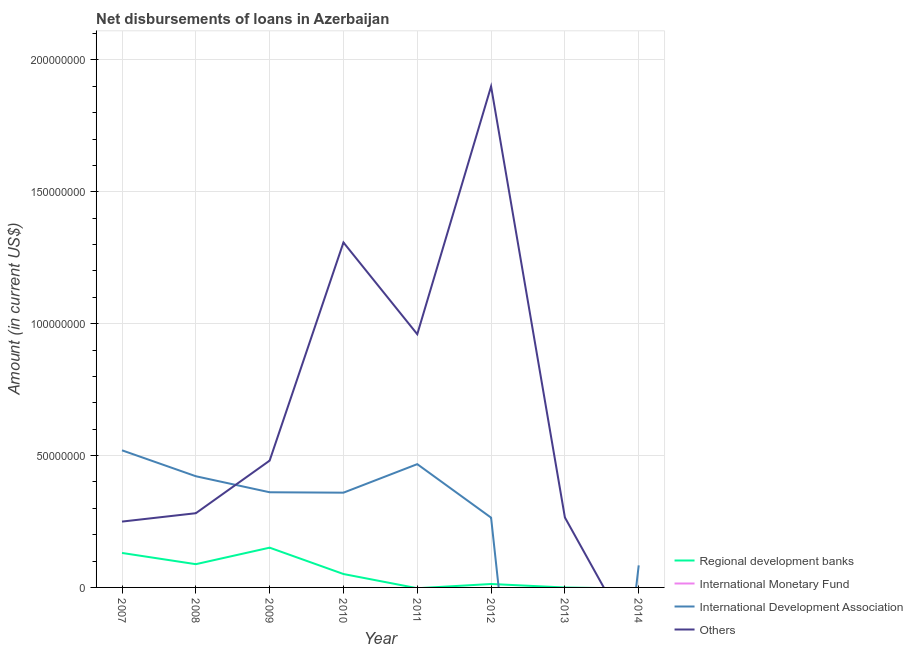Does the line corresponding to amount of loan disimbursed by other organisations intersect with the line corresponding to amount of loan disimbursed by international monetary fund?
Make the answer very short. Yes. What is the amount of loan disimbursed by international development association in 2008?
Make the answer very short. 4.22e+07. Across all years, what is the maximum amount of loan disimbursed by regional development banks?
Offer a terse response. 1.51e+07. Across all years, what is the minimum amount of loan disimbursed by international development association?
Your answer should be compact. 0. In which year was the amount of loan disimbursed by regional development banks maximum?
Offer a very short reply. 2009. What is the difference between the amount of loan disimbursed by regional development banks in 2007 and that in 2012?
Your answer should be compact. 1.18e+07. What is the difference between the amount of loan disimbursed by other organisations in 2009 and the amount of loan disimbursed by regional development banks in 2013?
Your answer should be compact. 4.81e+07. What is the average amount of loan disimbursed by other organisations per year?
Offer a very short reply. 6.81e+07. In the year 2007, what is the difference between the amount of loan disimbursed by international development association and amount of loan disimbursed by regional development banks?
Your answer should be very brief. 3.89e+07. What is the ratio of the amount of loan disimbursed by other organisations in 2007 to that in 2008?
Keep it short and to the point. 0.89. Is the amount of loan disimbursed by international development association in 2010 less than that in 2011?
Your response must be concise. Yes. What is the difference between the highest and the second highest amount of loan disimbursed by other organisations?
Offer a terse response. 5.92e+07. What is the difference between the highest and the lowest amount of loan disimbursed by other organisations?
Make the answer very short. 1.90e+08. In how many years, is the amount of loan disimbursed by other organisations greater than the average amount of loan disimbursed by other organisations taken over all years?
Offer a very short reply. 3. Is the sum of the amount of loan disimbursed by regional development banks in 2007 and 2010 greater than the maximum amount of loan disimbursed by other organisations across all years?
Provide a succinct answer. No. Is it the case that in every year, the sum of the amount of loan disimbursed by regional development banks and amount of loan disimbursed by international monetary fund is greater than the amount of loan disimbursed by international development association?
Keep it short and to the point. No. Does the amount of loan disimbursed by other organisations monotonically increase over the years?
Ensure brevity in your answer.  No. How many years are there in the graph?
Make the answer very short. 8. What is the difference between two consecutive major ticks on the Y-axis?
Make the answer very short. 5.00e+07. Does the graph contain grids?
Your answer should be very brief. Yes. What is the title of the graph?
Give a very brief answer. Net disbursements of loans in Azerbaijan. Does "Minerals" appear as one of the legend labels in the graph?
Keep it short and to the point. No. What is the label or title of the X-axis?
Give a very brief answer. Year. What is the label or title of the Y-axis?
Your answer should be very brief. Amount (in current US$). What is the Amount (in current US$) of Regional development banks in 2007?
Offer a very short reply. 1.31e+07. What is the Amount (in current US$) in International Monetary Fund in 2007?
Keep it short and to the point. 0. What is the Amount (in current US$) in International Development Association in 2007?
Provide a short and direct response. 5.20e+07. What is the Amount (in current US$) in Others in 2007?
Your answer should be compact. 2.50e+07. What is the Amount (in current US$) in Regional development banks in 2008?
Offer a terse response. 8.81e+06. What is the Amount (in current US$) of International Monetary Fund in 2008?
Give a very brief answer. 0. What is the Amount (in current US$) of International Development Association in 2008?
Offer a very short reply. 4.22e+07. What is the Amount (in current US$) of Others in 2008?
Your answer should be very brief. 2.81e+07. What is the Amount (in current US$) of Regional development banks in 2009?
Provide a succinct answer. 1.51e+07. What is the Amount (in current US$) in International Monetary Fund in 2009?
Offer a terse response. 0. What is the Amount (in current US$) in International Development Association in 2009?
Offer a terse response. 3.61e+07. What is the Amount (in current US$) of Others in 2009?
Your answer should be compact. 4.81e+07. What is the Amount (in current US$) of Regional development banks in 2010?
Provide a short and direct response. 5.08e+06. What is the Amount (in current US$) of International Development Association in 2010?
Your response must be concise. 3.59e+07. What is the Amount (in current US$) in Others in 2010?
Make the answer very short. 1.31e+08. What is the Amount (in current US$) of International Development Association in 2011?
Provide a short and direct response. 4.67e+07. What is the Amount (in current US$) in Others in 2011?
Provide a short and direct response. 9.60e+07. What is the Amount (in current US$) in Regional development banks in 2012?
Your answer should be compact. 1.30e+06. What is the Amount (in current US$) of International Development Association in 2012?
Offer a terse response. 2.65e+07. What is the Amount (in current US$) of Others in 2012?
Ensure brevity in your answer.  1.90e+08. What is the Amount (in current US$) of International Monetary Fund in 2013?
Ensure brevity in your answer.  0. What is the Amount (in current US$) of International Development Association in 2013?
Your response must be concise. 0. What is the Amount (in current US$) of Others in 2013?
Give a very brief answer. 2.65e+07. What is the Amount (in current US$) in Regional development banks in 2014?
Make the answer very short. 0. What is the Amount (in current US$) of International Development Association in 2014?
Keep it short and to the point. 8.36e+06. Across all years, what is the maximum Amount (in current US$) in Regional development banks?
Your answer should be compact. 1.51e+07. Across all years, what is the maximum Amount (in current US$) in International Development Association?
Ensure brevity in your answer.  5.20e+07. Across all years, what is the maximum Amount (in current US$) in Others?
Ensure brevity in your answer.  1.90e+08. Across all years, what is the minimum Amount (in current US$) of International Development Association?
Your answer should be compact. 0. What is the total Amount (in current US$) in Regional development banks in the graph?
Your answer should be compact. 4.33e+07. What is the total Amount (in current US$) in International Development Association in the graph?
Ensure brevity in your answer.  2.48e+08. What is the total Amount (in current US$) of Others in the graph?
Provide a succinct answer. 5.44e+08. What is the difference between the Amount (in current US$) in Regional development banks in 2007 and that in 2008?
Keep it short and to the point. 4.26e+06. What is the difference between the Amount (in current US$) of International Development Association in 2007 and that in 2008?
Your response must be concise. 9.82e+06. What is the difference between the Amount (in current US$) of Others in 2007 and that in 2008?
Ensure brevity in your answer.  -3.17e+06. What is the difference between the Amount (in current US$) of Regional development banks in 2007 and that in 2009?
Offer a very short reply. -2.00e+06. What is the difference between the Amount (in current US$) of International Development Association in 2007 and that in 2009?
Your response must be concise. 1.59e+07. What is the difference between the Amount (in current US$) of Others in 2007 and that in 2009?
Give a very brief answer. -2.31e+07. What is the difference between the Amount (in current US$) in Regional development banks in 2007 and that in 2010?
Your response must be concise. 7.98e+06. What is the difference between the Amount (in current US$) in International Development Association in 2007 and that in 2010?
Make the answer very short. 1.61e+07. What is the difference between the Amount (in current US$) of Others in 2007 and that in 2010?
Offer a very short reply. -1.06e+08. What is the difference between the Amount (in current US$) of International Development Association in 2007 and that in 2011?
Offer a very short reply. 5.24e+06. What is the difference between the Amount (in current US$) in Others in 2007 and that in 2011?
Your answer should be compact. -7.10e+07. What is the difference between the Amount (in current US$) of Regional development banks in 2007 and that in 2012?
Offer a terse response. 1.18e+07. What is the difference between the Amount (in current US$) in International Development Association in 2007 and that in 2012?
Give a very brief answer. 2.55e+07. What is the difference between the Amount (in current US$) in Others in 2007 and that in 2012?
Your answer should be compact. -1.65e+08. What is the difference between the Amount (in current US$) of Others in 2007 and that in 2013?
Your response must be concise. -1.57e+06. What is the difference between the Amount (in current US$) of International Development Association in 2007 and that in 2014?
Provide a short and direct response. 4.36e+07. What is the difference between the Amount (in current US$) in Regional development banks in 2008 and that in 2009?
Provide a succinct answer. -6.26e+06. What is the difference between the Amount (in current US$) of International Development Association in 2008 and that in 2009?
Your answer should be very brief. 6.08e+06. What is the difference between the Amount (in current US$) of Others in 2008 and that in 2009?
Your answer should be compact. -1.99e+07. What is the difference between the Amount (in current US$) of Regional development banks in 2008 and that in 2010?
Your answer should be compact. 3.73e+06. What is the difference between the Amount (in current US$) in International Development Association in 2008 and that in 2010?
Your response must be concise. 6.23e+06. What is the difference between the Amount (in current US$) of Others in 2008 and that in 2010?
Your answer should be compact. -1.03e+08. What is the difference between the Amount (in current US$) of International Development Association in 2008 and that in 2011?
Provide a short and direct response. -4.58e+06. What is the difference between the Amount (in current US$) of Others in 2008 and that in 2011?
Ensure brevity in your answer.  -6.79e+07. What is the difference between the Amount (in current US$) in Regional development banks in 2008 and that in 2012?
Keep it short and to the point. 7.52e+06. What is the difference between the Amount (in current US$) of International Development Association in 2008 and that in 2012?
Your response must be concise. 1.57e+07. What is the difference between the Amount (in current US$) in Others in 2008 and that in 2012?
Your answer should be very brief. -1.62e+08. What is the difference between the Amount (in current US$) in Others in 2008 and that in 2013?
Provide a short and direct response. 1.60e+06. What is the difference between the Amount (in current US$) in International Development Association in 2008 and that in 2014?
Your response must be concise. 3.38e+07. What is the difference between the Amount (in current US$) of Regional development banks in 2009 and that in 2010?
Your response must be concise. 9.99e+06. What is the difference between the Amount (in current US$) in International Development Association in 2009 and that in 2010?
Give a very brief answer. 1.56e+05. What is the difference between the Amount (in current US$) in Others in 2009 and that in 2010?
Ensure brevity in your answer.  -8.27e+07. What is the difference between the Amount (in current US$) in International Development Association in 2009 and that in 2011?
Give a very brief answer. -1.07e+07. What is the difference between the Amount (in current US$) of Others in 2009 and that in 2011?
Your response must be concise. -4.79e+07. What is the difference between the Amount (in current US$) of Regional development banks in 2009 and that in 2012?
Provide a succinct answer. 1.38e+07. What is the difference between the Amount (in current US$) of International Development Association in 2009 and that in 2012?
Your answer should be very brief. 9.63e+06. What is the difference between the Amount (in current US$) in Others in 2009 and that in 2012?
Ensure brevity in your answer.  -1.42e+08. What is the difference between the Amount (in current US$) of Others in 2009 and that in 2013?
Offer a terse response. 2.15e+07. What is the difference between the Amount (in current US$) in International Development Association in 2009 and that in 2014?
Give a very brief answer. 2.77e+07. What is the difference between the Amount (in current US$) in International Development Association in 2010 and that in 2011?
Offer a terse response. -1.08e+07. What is the difference between the Amount (in current US$) of Others in 2010 and that in 2011?
Keep it short and to the point. 3.48e+07. What is the difference between the Amount (in current US$) in Regional development banks in 2010 and that in 2012?
Give a very brief answer. 3.79e+06. What is the difference between the Amount (in current US$) in International Development Association in 2010 and that in 2012?
Provide a short and direct response. 9.47e+06. What is the difference between the Amount (in current US$) of Others in 2010 and that in 2012?
Make the answer very short. -5.92e+07. What is the difference between the Amount (in current US$) of Others in 2010 and that in 2013?
Offer a very short reply. 1.04e+08. What is the difference between the Amount (in current US$) of International Development Association in 2010 and that in 2014?
Provide a succinct answer. 2.76e+07. What is the difference between the Amount (in current US$) of International Development Association in 2011 and that in 2012?
Your answer should be compact. 2.03e+07. What is the difference between the Amount (in current US$) in Others in 2011 and that in 2012?
Your response must be concise. -9.39e+07. What is the difference between the Amount (in current US$) in Others in 2011 and that in 2013?
Your answer should be very brief. 6.95e+07. What is the difference between the Amount (in current US$) in International Development Association in 2011 and that in 2014?
Provide a succinct answer. 3.84e+07. What is the difference between the Amount (in current US$) in Others in 2012 and that in 2013?
Offer a very short reply. 1.63e+08. What is the difference between the Amount (in current US$) of International Development Association in 2012 and that in 2014?
Offer a terse response. 1.81e+07. What is the difference between the Amount (in current US$) in Regional development banks in 2007 and the Amount (in current US$) in International Development Association in 2008?
Make the answer very short. -2.91e+07. What is the difference between the Amount (in current US$) of Regional development banks in 2007 and the Amount (in current US$) of Others in 2008?
Your answer should be very brief. -1.51e+07. What is the difference between the Amount (in current US$) of International Development Association in 2007 and the Amount (in current US$) of Others in 2008?
Offer a terse response. 2.38e+07. What is the difference between the Amount (in current US$) in Regional development banks in 2007 and the Amount (in current US$) in International Development Association in 2009?
Your answer should be very brief. -2.30e+07. What is the difference between the Amount (in current US$) of Regional development banks in 2007 and the Amount (in current US$) of Others in 2009?
Offer a very short reply. -3.50e+07. What is the difference between the Amount (in current US$) of International Development Association in 2007 and the Amount (in current US$) of Others in 2009?
Offer a terse response. 3.90e+06. What is the difference between the Amount (in current US$) in Regional development banks in 2007 and the Amount (in current US$) in International Development Association in 2010?
Provide a short and direct response. -2.29e+07. What is the difference between the Amount (in current US$) of Regional development banks in 2007 and the Amount (in current US$) of Others in 2010?
Make the answer very short. -1.18e+08. What is the difference between the Amount (in current US$) of International Development Association in 2007 and the Amount (in current US$) of Others in 2010?
Offer a very short reply. -7.88e+07. What is the difference between the Amount (in current US$) of Regional development banks in 2007 and the Amount (in current US$) of International Development Association in 2011?
Your response must be concise. -3.37e+07. What is the difference between the Amount (in current US$) in Regional development banks in 2007 and the Amount (in current US$) in Others in 2011?
Make the answer very short. -8.29e+07. What is the difference between the Amount (in current US$) of International Development Association in 2007 and the Amount (in current US$) of Others in 2011?
Ensure brevity in your answer.  -4.40e+07. What is the difference between the Amount (in current US$) in Regional development banks in 2007 and the Amount (in current US$) in International Development Association in 2012?
Ensure brevity in your answer.  -1.34e+07. What is the difference between the Amount (in current US$) of Regional development banks in 2007 and the Amount (in current US$) of Others in 2012?
Your answer should be very brief. -1.77e+08. What is the difference between the Amount (in current US$) of International Development Association in 2007 and the Amount (in current US$) of Others in 2012?
Make the answer very short. -1.38e+08. What is the difference between the Amount (in current US$) of Regional development banks in 2007 and the Amount (in current US$) of Others in 2013?
Keep it short and to the point. -1.35e+07. What is the difference between the Amount (in current US$) in International Development Association in 2007 and the Amount (in current US$) in Others in 2013?
Provide a short and direct response. 2.54e+07. What is the difference between the Amount (in current US$) of Regional development banks in 2007 and the Amount (in current US$) of International Development Association in 2014?
Your response must be concise. 4.71e+06. What is the difference between the Amount (in current US$) of Regional development banks in 2008 and the Amount (in current US$) of International Development Association in 2009?
Your response must be concise. -2.73e+07. What is the difference between the Amount (in current US$) of Regional development banks in 2008 and the Amount (in current US$) of Others in 2009?
Give a very brief answer. -3.93e+07. What is the difference between the Amount (in current US$) in International Development Association in 2008 and the Amount (in current US$) in Others in 2009?
Keep it short and to the point. -5.92e+06. What is the difference between the Amount (in current US$) in Regional development banks in 2008 and the Amount (in current US$) in International Development Association in 2010?
Offer a terse response. -2.71e+07. What is the difference between the Amount (in current US$) of Regional development banks in 2008 and the Amount (in current US$) of Others in 2010?
Keep it short and to the point. -1.22e+08. What is the difference between the Amount (in current US$) of International Development Association in 2008 and the Amount (in current US$) of Others in 2010?
Ensure brevity in your answer.  -8.86e+07. What is the difference between the Amount (in current US$) in Regional development banks in 2008 and the Amount (in current US$) in International Development Association in 2011?
Make the answer very short. -3.79e+07. What is the difference between the Amount (in current US$) in Regional development banks in 2008 and the Amount (in current US$) in Others in 2011?
Offer a very short reply. -8.72e+07. What is the difference between the Amount (in current US$) of International Development Association in 2008 and the Amount (in current US$) of Others in 2011?
Your response must be concise. -5.39e+07. What is the difference between the Amount (in current US$) in Regional development banks in 2008 and the Amount (in current US$) in International Development Association in 2012?
Provide a short and direct response. -1.76e+07. What is the difference between the Amount (in current US$) in Regional development banks in 2008 and the Amount (in current US$) in Others in 2012?
Offer a terse response. -1.81e+08. What is the difference between the Amount (in current US$) of International Development Association in 2008 and the Amount (in current US$) of Others in 2012?
Your answer should be compact. -1.48e+08. What is the difference between the Amount (in current US$) in Regional development banks in 2008 and the Amount (in current US$) in Others in 2013?
Provide a succinct answer. -1.77e+07. What is the difference between the Amount (in current US$) of International Development Association in 2008 and the Amount (in current US$) of Others in 2013?
Your answer should be compact. 1.56e+07. What is the difference between the Amount (in current US$) in Regional development banks in 2008 and the Amount (in current US$) in International Development Association in 2014?
Give a very brief answer. 4.54e+05. What is the difference between the Amount (in current US$) in Regional development banks in 2009 and the Amount (in current US$) in International Development Association in 2010?
Your answer should be very brief. -2.09e+07. What is the difference between the Amount (in current US$) of Regional development banks in 2009 and the Amount (in current US$) of Others in 2010?
Provide a succinct answer. -1.16e+08. What is the difference between the Amount (in current US$) in International Development Association in 2009 and the Amount (in current US$) in Others in 2010?
Offer a very short reply. -9.47e+07. What is the difference between the Amount (in current US$) of Regional development banks in 2009 and the Amount (in current US$) of International Development Association in 2011?
Offer a terse response. -3.17e+07. What is the difference between the Amount (in current US$) of Regional development banks in 2009 and the Amount (in current US$) of Others in 2011?
Ensure brevity in your answer.  -8.09e+07. What is the difference between the Amount (in current US$) in International Development Association in 2009 and the Amount (in current US$) in Others in 2011?
Provide a short and direct response. -5.99e+07. What is the difference between the Amount (in current US$) of Regional development banks in 2009 and the Amount (in current US$) of International Development Association in 2012?
Provide a succinct answer. -1.14e+07. What is the difference between the Amount (in current US$) of Regional development banks in 2009 and the Amount (in current US$) of Others in 2012?
Your response must be concise. -1.75e+08. What is the difference between the Amount (in current US$) of International Development Association in 2009 and the Amount (in current US$) of Others in 2012?
Offer a very short reply. -1.54e+08. What is the difference between the Amount (in current US$) in Regional development banks in 2009 and the Amount (in current US$) in Others in 2013?
Keep it short and to the point. -1.15e+07. What is the difference between the Amount (in current US$) in International Development Association in 2009 and the Amount (in current US$) in Others in 2013?
Your answer should be very brief. 9.55e+06. What is the difference between the Amount (in current US$) in Regional development banks in 2009 and the Amount (in current US$) in International Development Association in 2014?
Make the answer very short. 6.71e+06. What is the difference between the Amount (in current US$) of Regional development banks in 2010 and the Amount (in current US$) of International Development Association in 2011?
Offer a very short reply. -4.17e+07. What is the difference between the Amount (in current US$) in Regional development banks in 2010 and the Amount (in current US$) in Others in 2011?
Ensure brevity in your answer.  -9.09e+07. What is the difference between the Amount (in current US$) of International Development Association in 2010 and the Amount (in current US$) of Others in 2011?
Your answer should be very brief. -6.01e+07. What is the difference between the Amount (in current US$) of Regional development banks in 2010 and the Amount (in current US$) of International Development Association in 2012?
Keep it short and to the point. -2.14e+07. What is the difference between the Amount (in current US$) in Regional development banks in 2010 and the Amount (in current US$) in Others in 2012?
Offer a very short reply. -1.85e+08. What is the difference between the Amount (in current US$) of International Development Association in 2010 and the Amount (in current US$) of Others in 2012?
Offer a very short reply. -1.54e+08. What is the difference between the Amount (in current US$) in Regional development banks in 2010 and the Amount (in current US$) in Others in 2013?
Provide a succinct answer. -2.14e+07. What is the difference between the Amount (in current US$) in International Development Association in 2010 and the Amount (in current US$) in Others in 2013?
Make the answer very short. 9.39e+06. What is the difference between the Amount (in current US$) in Regional development banks in 2010 and the Amount (in current US$) in International Development Association in 2014?
Offer a very short reply. -3.28e+06. What is the difference between the Amount (in current US$) in International Development Association in 2011 and the Amount (in current US$) in Others in 2012?
Give a very brief answer. -1.43e+08. What is the difference between the Amount (in current US$) in International Development Association in 2011 and the Amount (in current US$) in Others in 2013?
Give a very brief answer. 2.02e+07. What is the difference between the Amount (in current US$) in Regional development banks in 2012 and the Amount (in current US$) in Others in 2013?
Provide a short and direct response. -2.52e+07. What is the difference between the Amount (in current US$) of International Development Association in 2012 and the Amount (in current US$) of Others in 2013?
Keep it short and to the point. -8.20e+04. What is the difference between the Amount (in current US$) in Regional development banks in 2012 and the Amount (in current US$) in International Development Association in 2014?
Your answer should be very brief. -7.06e+06. What is the average Amount (in current US$) in Regional development banks per year?
Keep it short and to the point. 5.42e+06. What is the average Amount (in current US$) in International Monetary Fund per year?
Your answer should be compact. 0. What is the average Amount (in current US$) in International Development Association per year?
Give a very brief answer. 3.10e+07. What is the average Amount (in current US$) of Others per year?
Offer a very short reply. 6.81e+07. In the year 2007, what is the difference between the Amount (in current US$) in Regional development banks and Amount (in current US$) in International Development Association?
Your answer should be very brief. -3.89e+07. In the year 2007, what is the difference between the Amount (in current US$) of Regional development banks and Amount (in current US$) of Others?
Offer a very short reply. -1.19e+07. In the year 2007, what is the difference between the Amount (in current US$) in International Development Association and Amount (in current US$) in Others?
Ensure brevity in your answer.  2.70e+07. In the year 2008, what is the difference between the Amount (in current US$) in Regional development banks and Amount (in current US$) in International Development Association?
Keep it short and to the point. -3.33e+07. In the year 2008, what is the difference between the Amount (in current US$) of Regional development banks and Amount (in current US$) of Others?
Ensure brevity in your answer.  -1.93e+07. In the year 2008, what is the difference between the Amount (in current US$) in International Development Association and Amount (in current US$) in Others?
Provide a succinct answer. 1.40e+07. In the year 2009, what is the difference between the Amount (in current US$) in Regional development banks and Amount (in current US$) in International Development Association?
Offer a very short reply. -2.10e+07. In the year 2009, what is the difference between the Amount (in current US$) of Regional development banks and Amount (in current US$) of Others?
Your response must be concise. -3.30e+07. In the year 2009, what is the difference between the Amount (in current US$) of International Development Association and Amount (in current US$) of Others?
Give a very brief answer. -1.20e+07. In the year 2010, what is the difference between the Amount (in current US$) in Regional development banks and Amount (in current US$) in International Development Association?
Offer a very short reply. -3.08e+07. In the year 2010, what is the difference between the Amount (in current US$) of Regional development banks and Amount (in current US$) of Others?
Make the answer very short. -1.26e+08. In the year 2010, what is the difference between the Amount (in current US$) of International Development Association and Amount (in current US$) of Others?
Your answer should be very brief. -9.49e+07. In the year 2011, what is the difference between the Amount (in current US$) of International Development Association and Amount (in current US$) of Others?
Give a very brief answer. -4.93e+07. In the year 2012, what is the difference between the Amount (in current US$) in Regional development banks and Amount (in current US$) in International Development Association?
Provide a succinct answer. -2.52e+07. In the year 2012, what is the difference between the Amount (in current US$) of Regional development banks and Amount (in current US$) of Others?
Offer a very short reply. -1.89e+08. In the year 2012, what is the difference between the Amount (in current US$) of International Development Association and Amount (in current US$) of Others?
Ensure brevity in your answer.  -1.64e+08. What is the ratio of the Amount (in current US$) in Regional development banks in 2007 to that in 2008?
Keep it short and to the point. 1.48. What is the ratio of the Amount (in current US$) in International Development Association in 2007 to that in 2008?
Provide a short and direct response. 1.23. What is the ratio of the Amount (in current US$) in Others in 2007 to that in 2008?
Your answer should be very brief. 0.89. What is the ratio of the Amount (in current US$) in Regional development banks in 2007 to that in 2009?
Make the answer very short. 0.87. What is the ratio of the Amount (in current US$) of International Development Association in 2007 to that in 2009?
Your answer should be very brief. 1.44. What is the ratio of the Amount (in current US$) in Others in 2007 to that in 2009?
Your answer should be very brief. 0.52. What is the ratio of the Amount (in current US$) of Regional development banks in 2007 to that in 2010?
Make the answer very short. 2.57. What is the ratio of the Amount (in current US$) of International Development Association in 2007 to that in 2010?
Ensure brevity in your answer.  1.45. What is the ratio of the Amount (in current US$) of Others in 2007 to that in 2010?
Give a very brief answer. 0.19. What is the ratio of the Amount (in current US$) of International Development Association in 2007 to that in 2011?
Keep it short and to the point. 1.11. What is the ratio of the Amount (in current US$) of Others in 2007 to that in 2011?
Your answer should be compact. 0.26. What is the ratio of the Amount (in current US$) of Regional development banks in 2007 to that in 2012?
Offer a very short reply. 10.08. What is the ratio of the Amount (in current US$) of International Development Association in 2007 to that in 2012?
Your response must be concise. 1.97. What is the ratio of the Amount (in current US$) of Others in 2007 to that in 2012?
Give a very brief answer. 0.13. What is the ratio of the Amount (in current US$) of Others in 2007 to that in 2013?
Offer a terse response. 0.94. What is the ratio of the Amount (in current US$) of International Development Association in 2007 to that in 2014?
Keep it short and to the point. 6.22. What is the ratio of the Amount (in current US$) of Regional development banks in 2008 to that in 2009?
Offer a terse response. 0.58. What is the ratio of the Amount (in current US$) of International Development Association in 2008 to that in 2009?
Your response must be concise. 1.17. What is the ratio of the Amount (in current US$) of Others in 2008 to that in 2009?
Your answer should be very brief. 0.59. What is the ratio of the Amount (in current US$) of Regional development banks in 2008 to that in 2010?
Offer a terse response. 1.73. What is the ratio of the Amount (in current US$) of International Development Association in 2008 to that in 2010?
Your answer should be very brief. 1.17. What is the ratio of the Amount (in current US$) of Others in 2008 to that in 2010?
Your answer should be compact. 0.22. What is the ratio of the Amount (in current US$) of International Development Association in 2008 to that in 2011?
Give a very brief answer. 0.9. What is the ratio of the Amount (in current US$) of Others in 2008 to that in 2011?
Make the answer very short. 0.29. What is the ratio of the Amount (in current US$) in Regional development banks in 2008 to that in 2012?
Make the answer very short. 6.8. What is the ratio of the Amount (in current US$) of International Development Association in 2008 to that in 2012?
Offer a very short reply. 1.59. What is the ratio of the Amount (in current US$) in Others in 2008 to that in 2012?
Give a very brief answer. 0.15. What is the ratio of the Amount (in current US$) of Others in 2008 to that in 2013?
Give a very brief answer. 1.06. What is the ratio of the Amount (in current US$) of International Development Association in 2008 to that in 2014?
Keep it short and to the point. 5.04. What is the ratio of the Amount (in current US$) of Regional development banks in 2009 to that in 2010?
Offer a terse response. 2.96. What is the ratio of the Amount (in current US$) in Others in 2009 to that in 2010?
Ensure brevity in your answer.  0.37. What is the ratio of the Amount (in current US$) of International Development Association in 2009 to that in 2011?
Ensure brevity in your answer.  0.77. What is the ratio of the Amount (in current US$) of Others in 2009 to that in 2011?
Offer a terse response. 0.5. What is the ratio of the Amount (in current US$) in Regional development banks in 2009 to that in 2012?
Ensure brevity in your answer.  11.62. What is the ratio of the Amount (in current US$) in International Development Association in 2009 to that in 2012?
Your response must be concise. 1.36. What is the ratio of the Amount (in current US$) in Others in 2009 to that in 2012?
Offer a terse response. 0.25. What is the ratio of the Amount (in current US$) in Others in 2009 to that in 2013?
Your answer should be very brief. 1.81. What is the ratio of the Amount (in current US$) of International Development Association in 2009 to that in 2014?
Your response must be concise. 4.32. What is the ratio of the Amount (in current US$) in International Development Association in 2010 to that in 2011?
Give a very brief answer. 0.77. What is the ratio of the Amount (in current US$) in Others in 2010 to that in 2011?
Give a very brief answer. 1.36. What is the ratio of the Amount (in current US$) in Regional development banks in 2010 to that in 2012?
Give a very brief answer. 3.92. What is the ratio of the Amount (in current US$) of International Development Association in 2010 to that in 2012?
Your answer should be very brief. 1.36. What is the ratio of the Amount (in current US$) of Others in 2010 to that in 2012?
Give a very brief answer. 0.69. What is the ratio of the Amount (in current US$) of Others in 2010 to that in 2013?
Your answer should be very brief. 4.93. What is the ratio of the Amount (in current US$) of International Development Association in 2010 to that in 2014?
Offer a terse response. 4.3. What is the ratio of the Amount (in current US$) in International Development Association in 2011 to that in 2012?
Offer a very short reply. 1.77. What is the ratio of the Amount (in current US$) of Others in 2011 to that in 2012?
Give a very brief answer. 0.51. What is the ratio of the Amount (in current US$) of Others in 2011 to that in 2013?
Provide a succinct answer. 3.62. What is the ratio of the Amount (in current US$) of International Development Association in 2011 to that in 2014?
Give a very brief answer. 5.59. What is the ratio of the Amount (in current US$) in Others in 2012 to that in 2013?
Offer a terse response. 7.16. What is the ratio of the Amount (in current US$) in International Development Association in 2012 to that in 2014?
Make the answer very short. 3.16. What is the difference between the highest and the second highest Amount (in current US$) in Regional development banks?
Keep it short and to the point. 2.00e+06. What is the difference between the highest and the second highest Amount (in current US$) of International Development Association?
Provide a short and direct response. 5.24e+06. What is the difference between the highest and the second highest Amount (in current US$) in Others?
Your response must be concise. 5.92e+07. What is the difference between the highest and the lowest Amount (in current US$) in Regional development banks?
Provide a short and direct response. 1.51e+07. What is the difference between the highest and the lowest Amount (in current US$) of International Development Association?
Keep it short and to the point. 5.20e+07. What is the difference between the highest and the lowest Amount (in current US$) of Others?
Offer a terse response. 1.90e+08. 